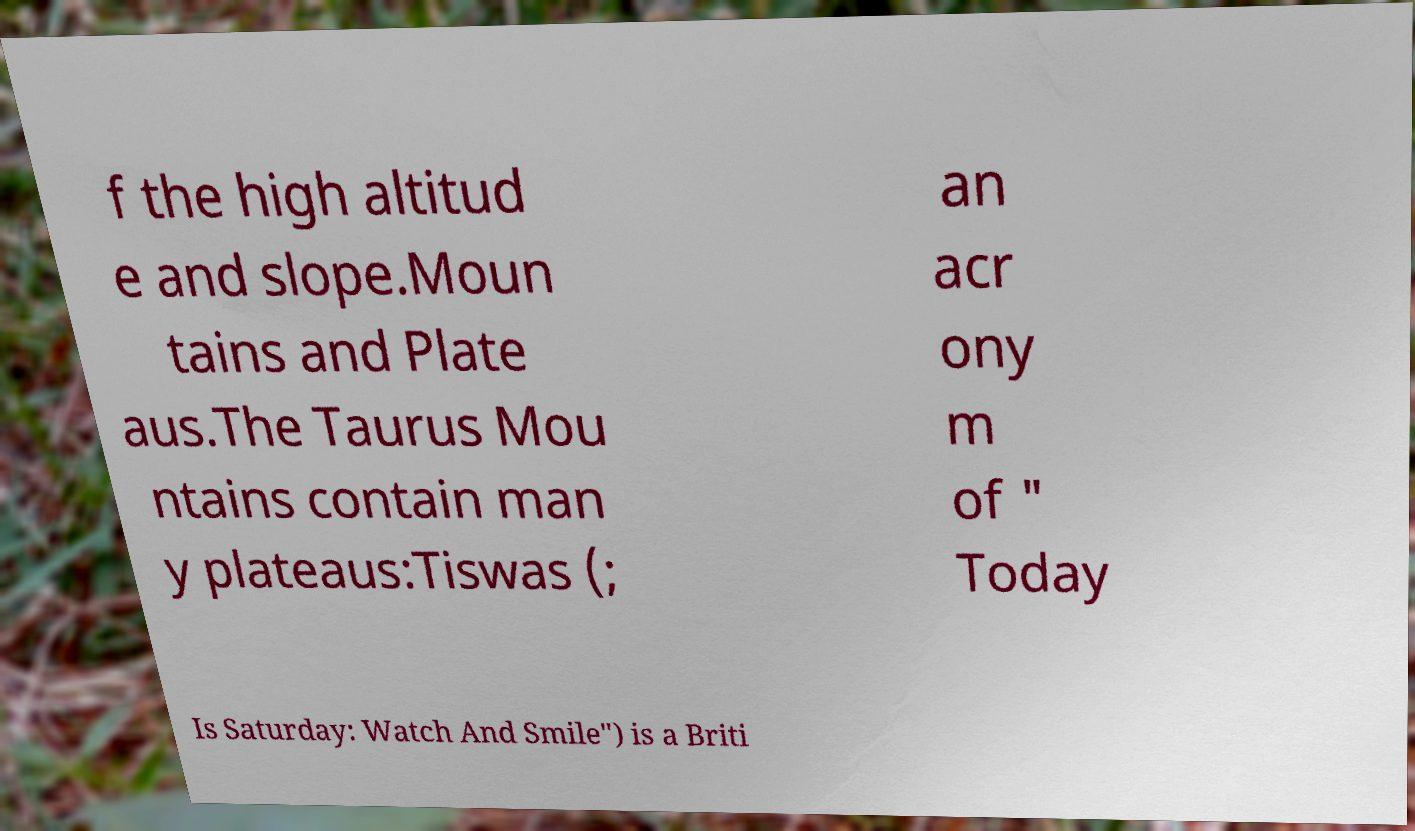Could you assist in decoding the text presented in this image and type it out clearly? f the high altitud e and slope.Moun tains and Plate aus.The Taurus Mou ntains contain man y plateaus:Tiswas (; an acr ony m of " Today Is Saturday: Watch And Smile") is a Briti 